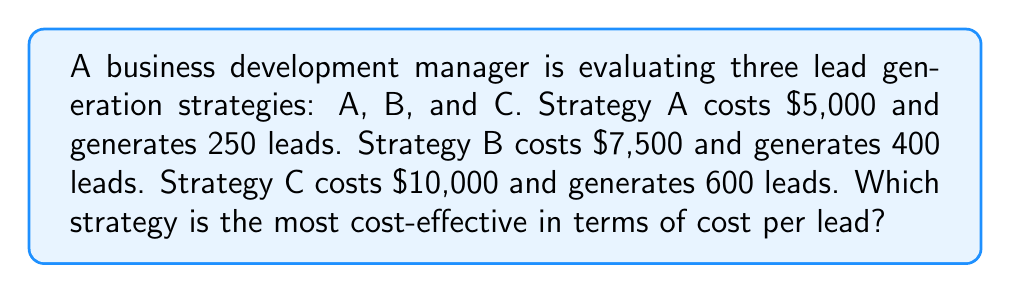Solve this math problem. To determine the most cost-effective strategy, we need to calculate the cost per lead for each strategy:

1. Strategy A:
   Cost per lead = Total cost / Number of leads
   $$ \text{Cost per lead}_A = \frac{\$5,000}{250} = \$20 \text{ per lead} $$

2. Strategy B:
   $$ \text{Cost per lead}_B = \frac{\$7,500}{400} = \$18.75 \text{ per lead} $$

3. Strategy C:
   $$ \text{Cost per lead}_C = \frac{\$10,000}{600} = \$16.67 \text{ per lead} $$

Comparing the results:
Strategy A: $20 per lead
Strategy B: $18.75 per lead
Strategy C: $16.67 per lead

The strategy with the lowest cost per lead is the most cost-effective. In this case, Strategy C has the lowest cost per lead at $16.67.
Answer: Strategy C 